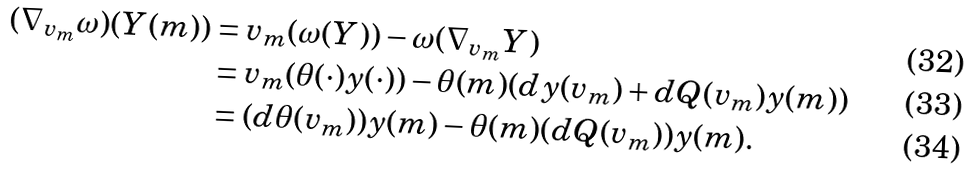<formula> <loc_0><loc_0><loc_500><loc_500>( \nabla _ { v _ { m } } \omega ) ( Y ( m ) ) & = v _ { m } ( \omega ( Y ) ) - \omega ( \nabla _ { v _ { m } } Y ) \\ & = v _ { m } ( \theta ( \cdot ) y ( \cdot ) ) - \theta ( m ) ( d y ( v _ { m } ) + d Q ( v _ { m } ) y ( m ) ) \\ & = ( d \theta ( v _ { m } ) ) y ( m ) - \theta ( m ) ( d Q ( v _ { m } ) ) y ( m ) .</formula> 